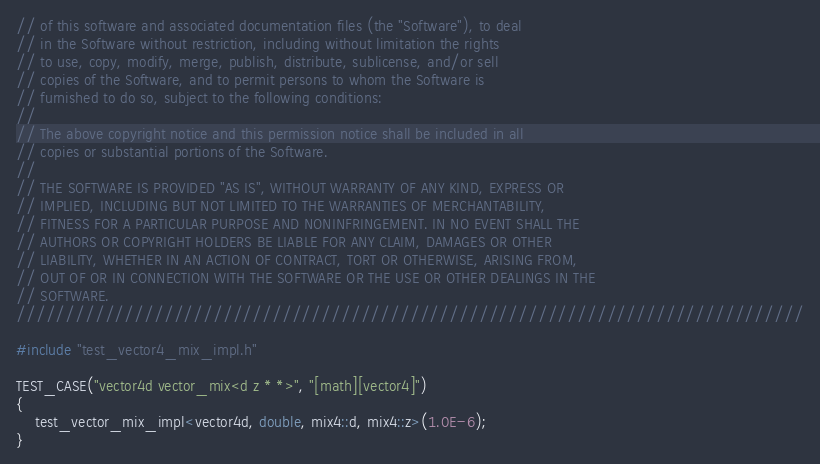<code> <loc_0><loc_0><loc_500><loc_500><_C++_>// of this software and associated documentation files (the "Software"), to deal
// in the Software without restriction, including without limitation the rights
// to use, copy, modify, merge, publish, distribute, sublicense, and/or sell
// copies of the Software, and to permit persons to whom the Software is
// furnished to do so, subject to the following conditions:
//
// The above copyright notice and this permission notice shall be included in all
// copies or substantial portions of the Software.
//
// THE SOFTWARE IS PROVIDED "AS IS", WITHOUT WARRANTY OF ANY KIND, EXPRESS OR
// IMPLIED, INCLUDING BUT NOT LIMITED TO THE WARRANTIES OF MERCHANTABILITY,
// FITNESS FOR A PARTICULAR PURPOSE AND NONINFRINGEMENT. IN NO EVENT SHALL THE
// AUTHORS OR COPYRIGHT HOLDERS BE LIABLE FOR ANY CLAIM, DAMAGES OR OTHER
// LIABILITY, WHETHER IN AN ACTION OF CONTRACT, TORT OR OTHERWISE, ARISING FROM,
// OUT OF OR IN CONNECTION WITH THE SOFTWARE OR THE USE OR OTHER DEALINGS IN THE
// SOFTWARE.
////////////////////////////////////////////////////////////////////////////////

#include "test_vector4_mix_impl.h"

TEST_CASE("vector4d vector_mix<d z * *>", "[math][vector4]")
{
	test_vector_mix_impl<vector4d, double, mix4::d, mix4::z>(1.0E-6);
}
</code> 